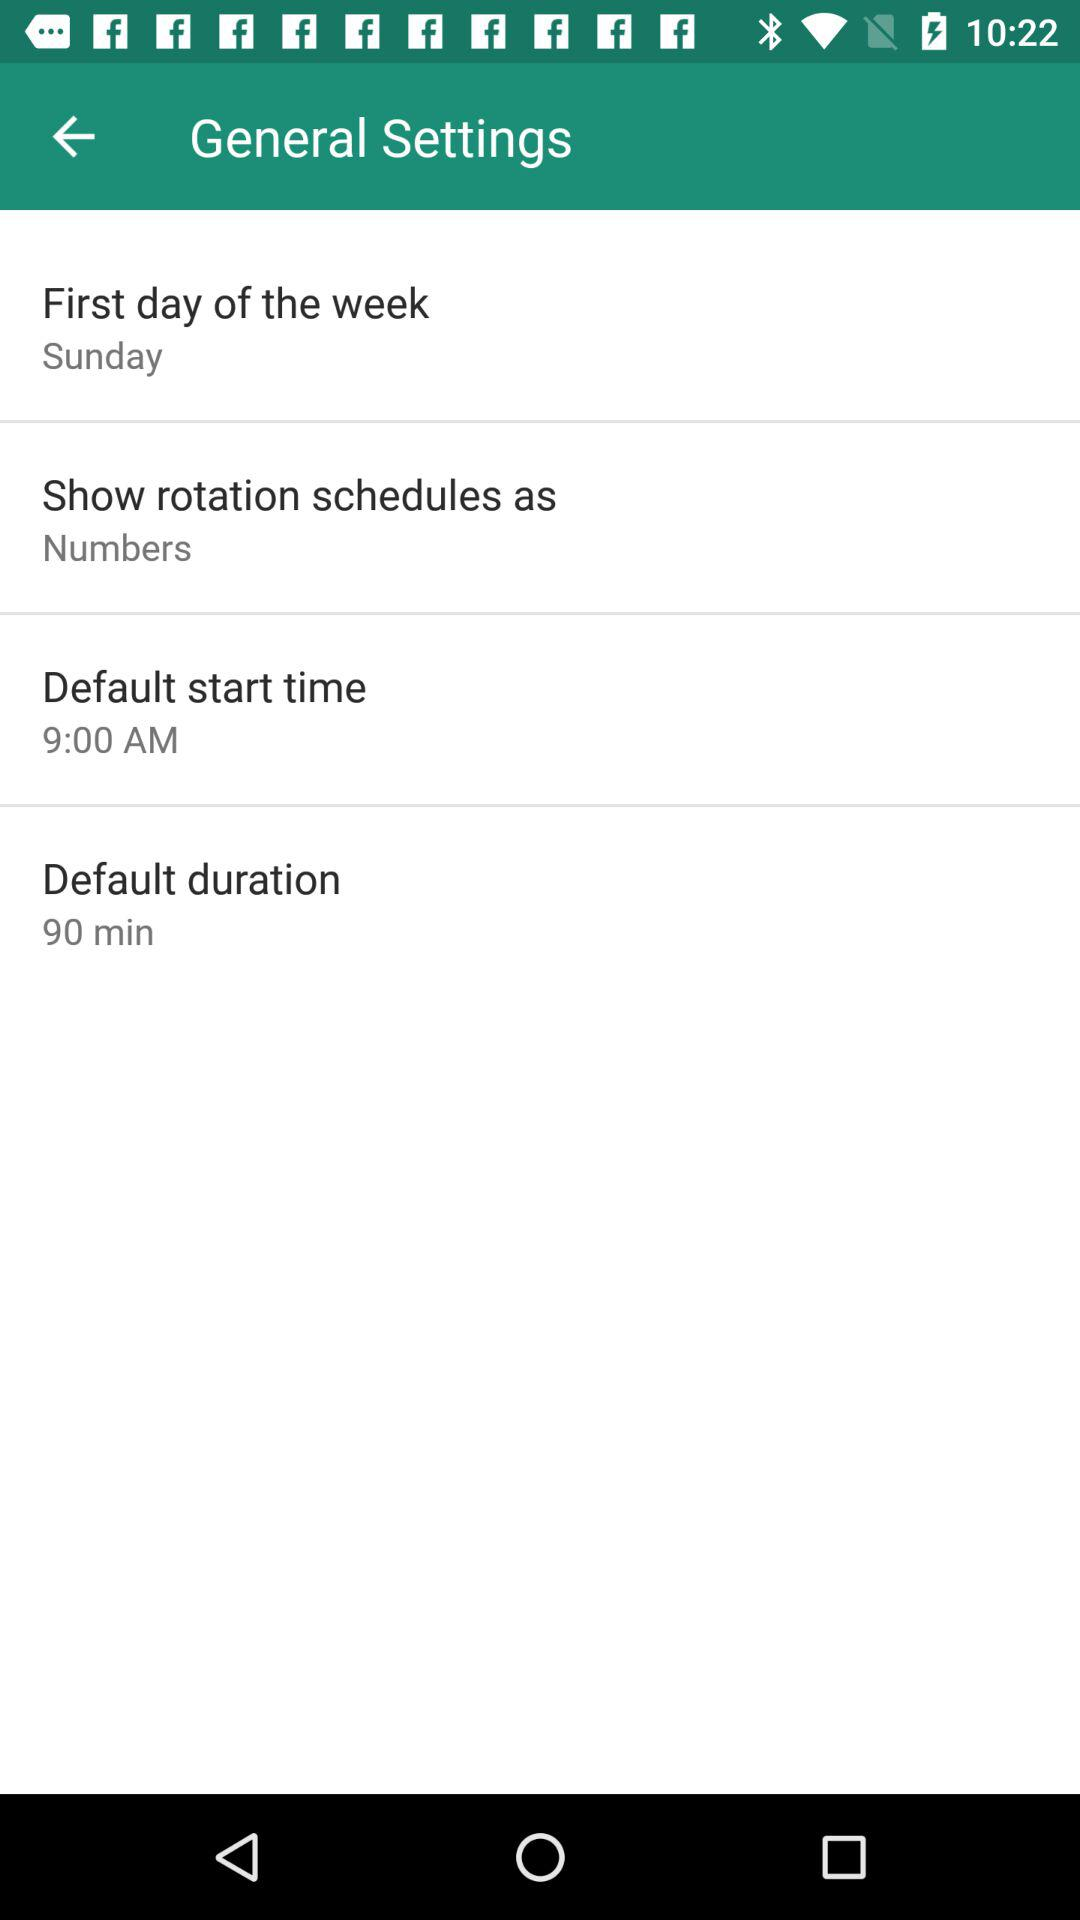What is the default start time? The default start time is 9:00 AM. 